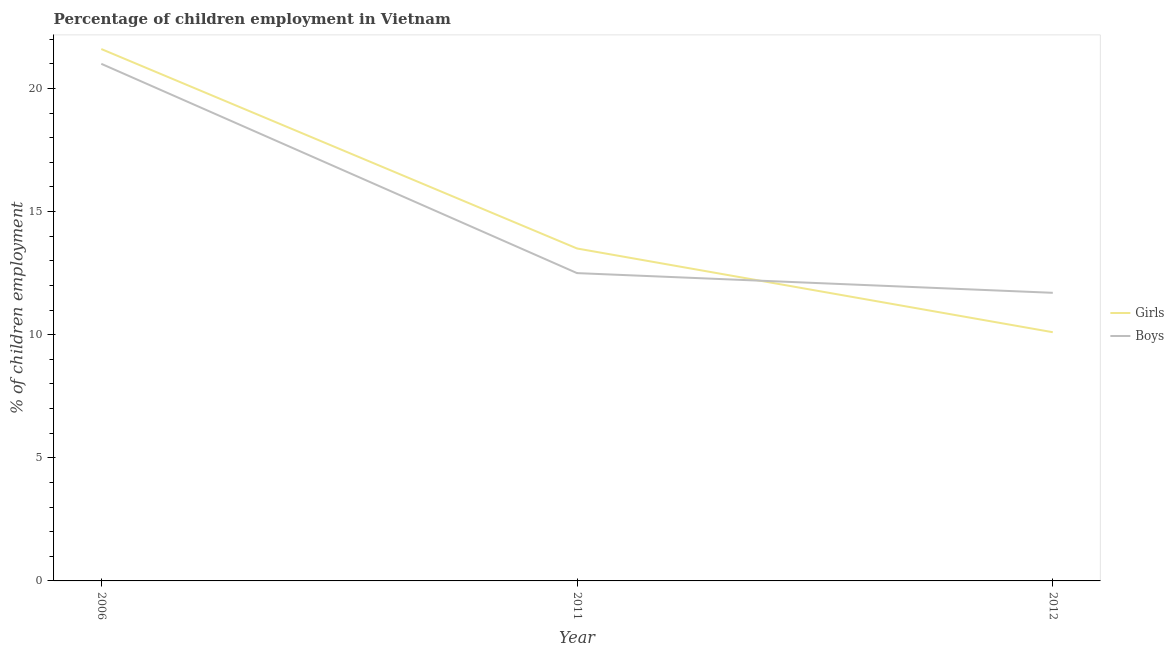How many different coloured lines are there?
Offer a terse response. 2. Does the line corresponding to percentage of employed boys intersect with the line corresponding to percentage of employed girls?
Your answer should be compact. Yes. In which year was the percentage of employed boys maximum?
Offer a very short reply. 2006. What is the total percentage of employed girls in the graph?
Make the answer very short. 45.2. What is the difference between the percentage of employed boys in 2006 and that in 2011?
Keep it short and to the point. 8.5. What is the average percentage of employed girls per year?
Your response must be concise. 15.07. In the year 2012, what is the difference between the percentage of employed girls and percentage of employed boys?
Keep it short and to the point. -1.6. What is the ratio of the percentage of employed boys in 2006 to that in 2012?
Offer a terse response. 1.79. Is the difference between the percentage of employed girls in 2006 and 2012 greater than the difference between the percentage of employed boys in 2006 and 2012?
Your response must be concise. Yes. What is the difference between the highest and the second highest percentage of employed boys?
Give a very brief answer. 8.5. Is the sum of the percentage of employed boys in 2006 and 2011 greater than the maximum percentage of employed girls across all years?
Give a very brief answer. Yes. Does the percentage of employed boys monotonically increase over the years?
Give a very brief answer. No. Is the percentage of employed boys strictly less than the percentage of employed girls over the years?
Your response must be concise. No. How many years are there in the graph?
Provide a succinct answer. 3. Are the values on the major ticks of Y-axis written in scientific E-notation?
Provide a short and direct response. No. Does the graph contain any zero values?
Keep it short and to the point. No. How many legend labels are there?
Give a very brief answer. 2. How are the legend labels stacked?
Your answer should be compact. Vertical. What is the title of the graph?
Provide a short and direct response. Percentage of children employment in Vietnam. What is the label or title of the X-axis?
Provide a succinct answer. Year. What is the label or title of the Y-axis?
Provide a succinct answer. % of children employment. What is the % of children employment of Girls in 2006?
Offer a terse response. 21.6. What is the % of children employment in Girls in 2012?
Offer a very short reply. 10.1. What is the % of children employment of Boys in 2012?
Offer a very short reply. 11.7. Across all years, what is the maximum % of children employment in Girls?
Your response must be concise. 21.6. Across all years, what is the minimum % of children employment in Girls?
Offer a very short reply. 10.1. What is the total % of children employment of Girls in the graph?
Ensure brevity in your answer.  45.2. What is the total % of children employment in Boys in the graph?
Provide a succinct answer. 45.2. What is the difference between the % of children employment of Girls in 2006 and that in 2011?
Offer a terse response. 8.1. What is the difference between the % of children employment in Girls in 2006 and that in 2012?
Your answer should be compact. 11.5. What is the difference between the % of children employment of Boys in 2006 and that in 2012?
Keep it short and to the point. 9.3. What is the difference between the % of children employment in Girls in 2011 and that in 2012?
Make the answer very short. 3.4. What is the difference between the % of children employment in Girls in 2006 and the % of children employment in Boys in 2012?
Provide a short and direct response. 9.9. What is the average % of children employment of Girls per year?
Make the answer very short. 15.07. What is the average % of children employment in Boys per year?
Offer a very short reply. 15.07. What is the ratio of the % of children employment of Girls in 2006 to that in 2011?
Your answer should be very brief. 1.6. What is the ratio of the % of children employment in Boys in 2006 to that in 2011?
Your answer should be compact. 1.68. What is the ratio of the % of children employment of Girls in 2006 to that in 2012?
Keep it short and to the point. 2.14. What is the ratio of the % of children employment of Boys in 2006 to that in 2012?
Your response must be concise. 1.79. What is the ratio of the % of children employment in Girls in 2011 to that in 2012?
Make the answer very short. 1.34. What is the ratio of the % of children employment in Boys in 2011 to that in 2012?
Provide a short and direct response. 1.07. 